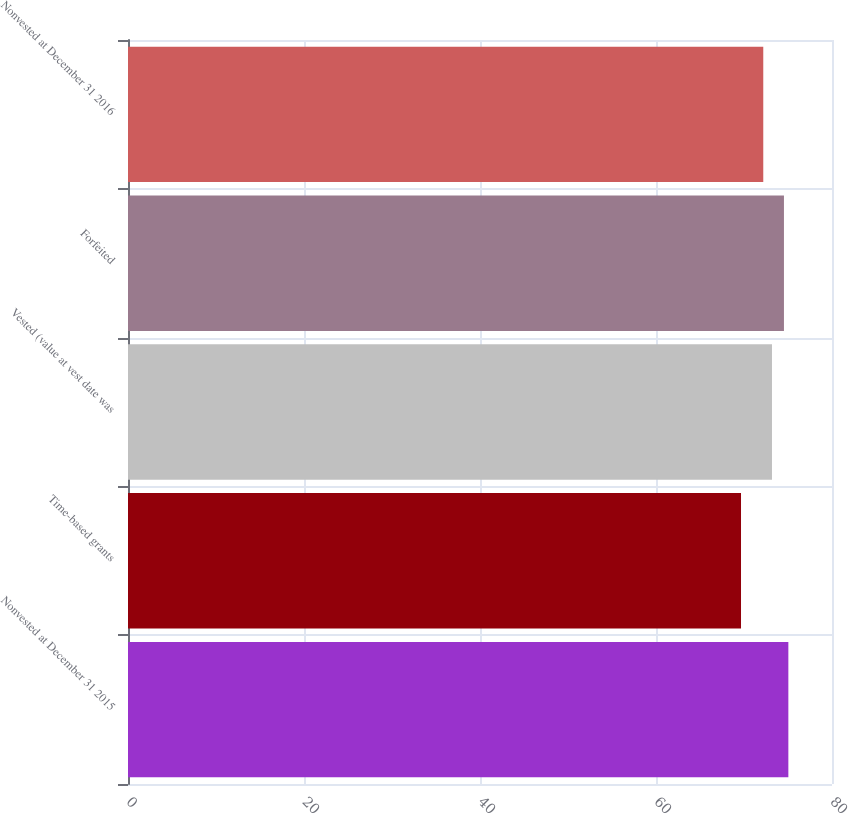Convert chart. <chart><loc_0><loc_0><loc_500><loc_500><bar_chart><fcel>Nonvested at December 31 2015<fcel>Time-based grants<fcel>Vested (value at vest date was<fcel>Forfeited<fcel>Nonvested at December 31 2016<nl><fcel>75.04<fcel>69.66<fcel>73.18<fcel>74.54<fcel>72.19<nl></chart> 